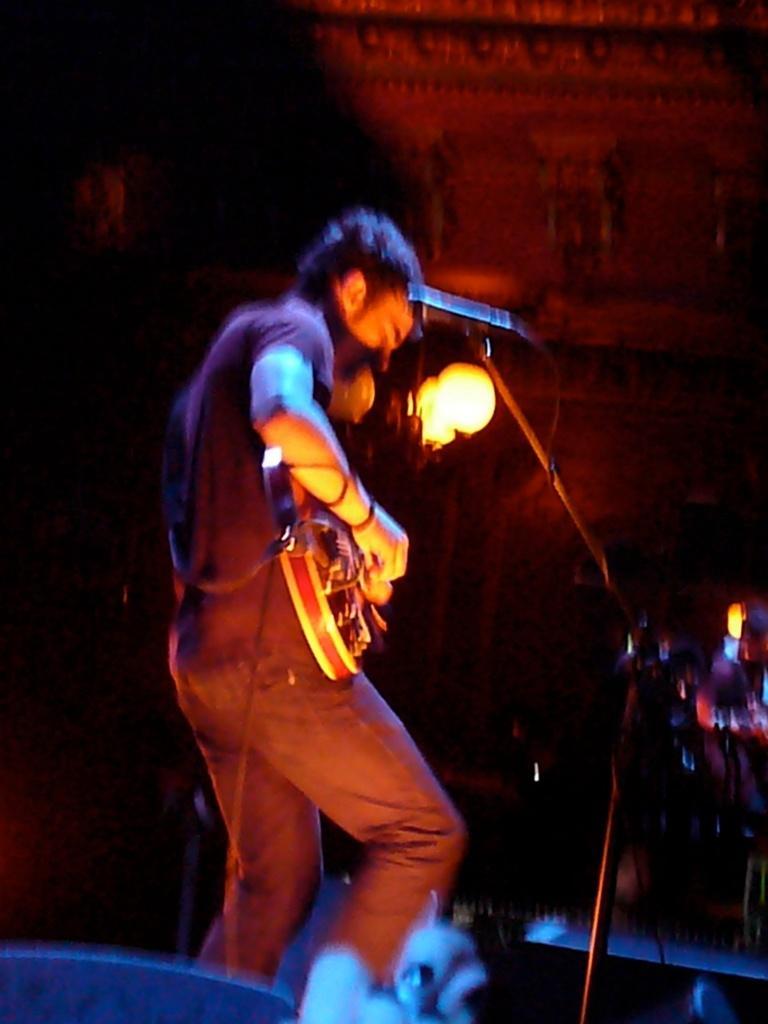Can you describe this image briefly? In this picture we can see man holding guitar in his hand and playing and in front of him there is mic, light and in background it is dark. 